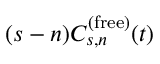<formula> <loc_0><loc_0><loc_500><loc_500>( s - n ) C _ { s , n } ^ { ( f r e e ) } ( t )</formula> 